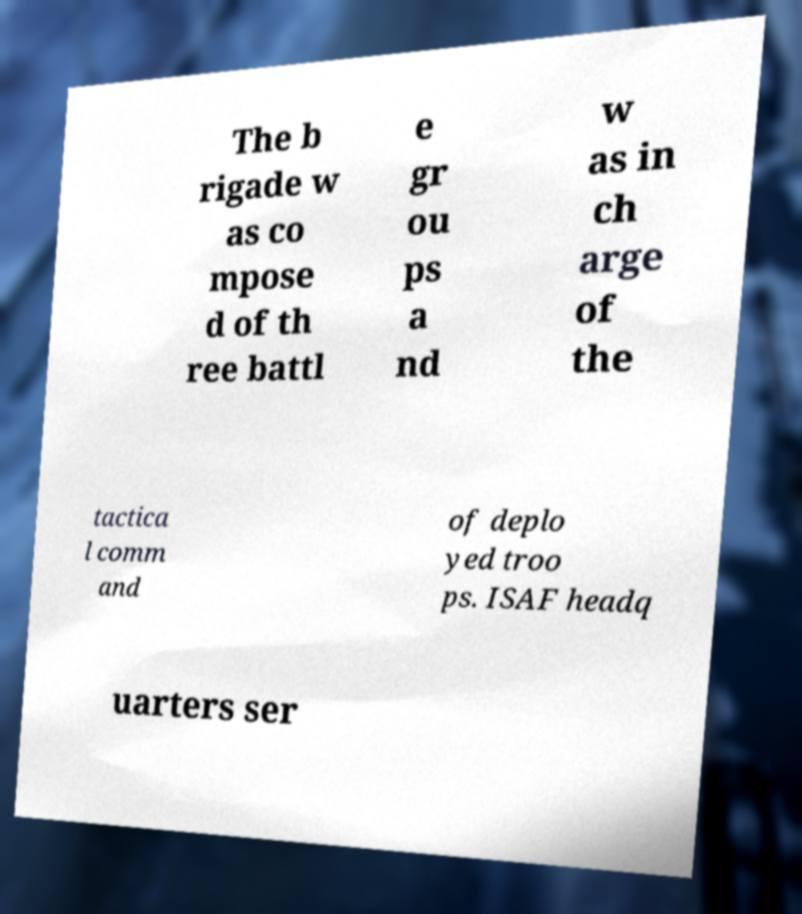Please identify and transcribe the text found in this image. The b rigade w as co mpose d of th ree battl e gr ou ps a nd w as in ch arge of the tactica l comm and of deplo yed troo ps. ISAF headq uarters ser 